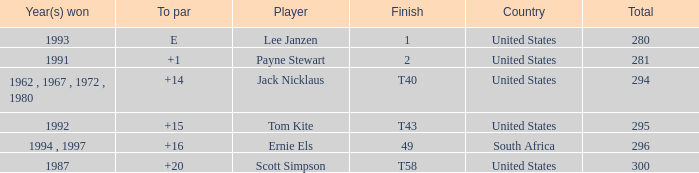What is the Total of the Player with a Finish of 1? 1.0. 